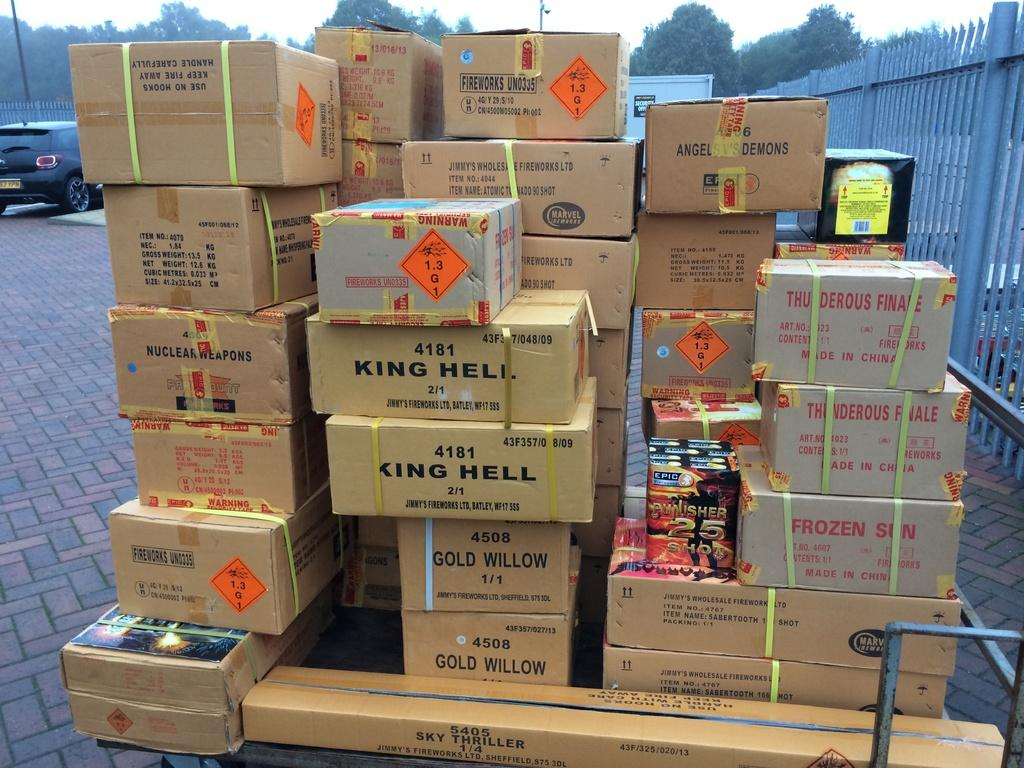Provide a one-sentence caption for the provided image. A stack of cardboard boxes includes two that say King Hell on them. 